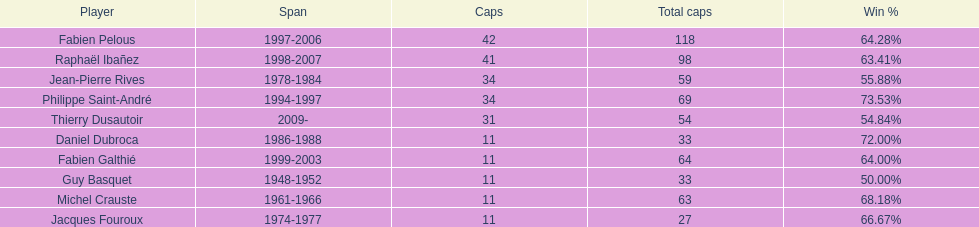Could you help me parse every detail presented in this table? {'header': ['Player', 'Span', 'Caps', 'Total caps', 'Win\xa0%'], 'rows': [['Fabien Pelous', '1997-2006', '42', '118', '64.28%'], ['Raphaël Ibañez', '1998-2007', '41', '98', '63.41%'], ['Jean-Pierre Rives', '1978-1984', '34', '59', '55.88%'], ['Philippe Saint-André', '1994-1997', '34', '69', '73.53%'], ['Thierry Dusautoir', '2009-', '31', '54', '54.84%'], ['Daniel Dubroca', '1986-1988', '11', '33', '72.00%'], ['Fabien Galthié', '1999-2003', '11', '64', '64.00%'], ['Guy Basquet', '1948-1952', '11', '33', '50.00%'], ['Michel Crauste', '1961-1966', '11', '63', '68.18%'], ['Jacques Fouroux', '1974-1977', '11', '27', '66.67%']]} Which player has the highest win percentage? Philippe Saint-André. 